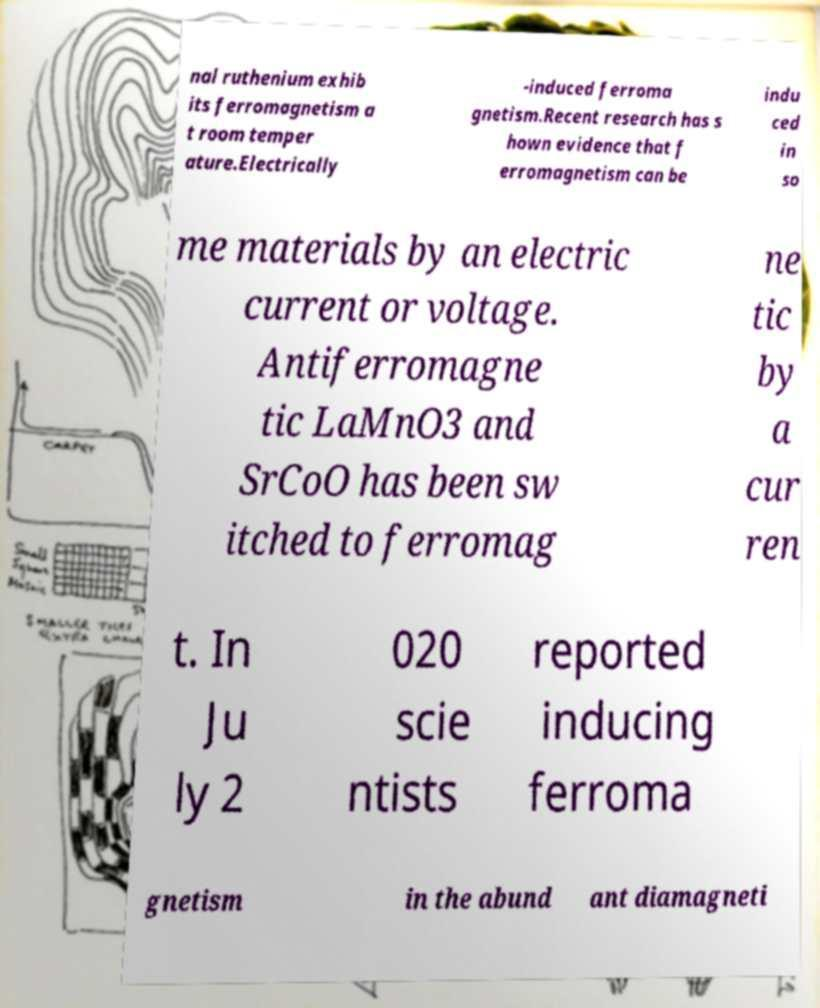Please identify and transcribe the text found in this image. nal ruthenium exhib its ferromagnetism a t room temper ature.Electrically -induced ferroma gnetism.Recent research has s hown evidence that f erromagnetism can be indu ced in so me materials by an electric current or voltage. Antiferromagne tic LaMnO3 and SrCoO has been sw itched to ferromag ne tic by a cur ren t. In Ju ly 2 020 scie ntists reported inducing ferroma gnetism in the abund ant diamagneti 